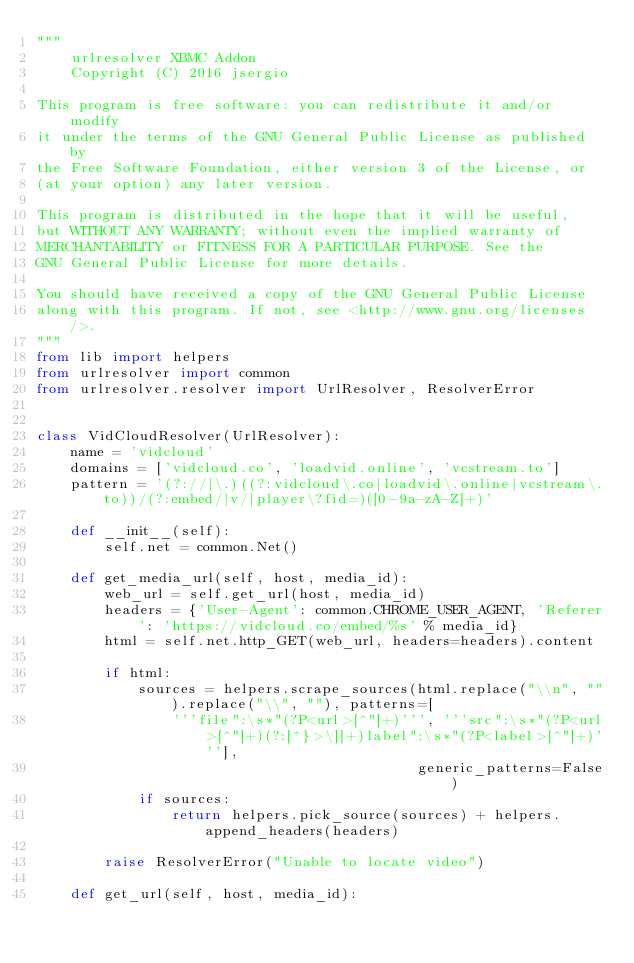<code> <loc_0><loc_0><loc_500><loc_500><_Python_>"""
    urlresolver XBMC Addon
    Copyright (C) 2016 jsergio

This program is free software: you can redistribute it and/or modify
it under the terms of the GNU General Public License as published by
the Free Software Foundation, either version 3 of the License, or
(at your option) any later version.

This program is distributed in the hope that it will be useful,
but WITHOUT ANY WARRANTY; without even the implied warranty of
MERCHANTABILITY or FITNESS FOR A PARTICULAR PURPOSE. See the
GNU General Public License for more details.

You should have received a copy of the GNU General Public License
along with this program. If not, see <http://www.gnu.org/licenses/>.
"""
from lib import helpers
from urlresolver import common
from urlresolver.resolver import UrlResolver, ResolverError


class VidCloudResolver(UrlResolver):
    name = 'vidcloud'
    domains = ['vidcloud.co', 'loadvid.online', 'vcstream.to']
    pattern = '(?://|\.)((?:vidcloud\.co|loadvid\.online|vcstream\.to))/(?:embed/|v/|player\?fid=)([0-9a-zA-Z]+)'

    def __init__(self):
        self.net = common.Net()

    def get_media_url(self, host, media_id):
        web_url = self.get_url(host, media_id)
        headers = {'User-Agent': common.CHROME_USER_AGENT, 'Referer': 'https://vidcloud.co/embed/%s' % media_id}
        html = self.net.http_GET(web_url, headers=headers).content

        if html:
            sources = helpers.scrape_sources(html.replace("\\n", "").replace("\\", ""), patterns=[
                '''file":\s*"(?P<url>[^"]+)''', '''src":\s*"(?P<url>[^"]+)(?:[^}>\]]+)label":\s*"(?P<label>[^"]+)'''],
                                             generic_patterns=False)
            if sources:
                return helpers.pick_source(sources) + helpers.append_headers(headers)

        raise ResolverError("Unable to locate video")

    def get_url(self, host, media_id):</code> 